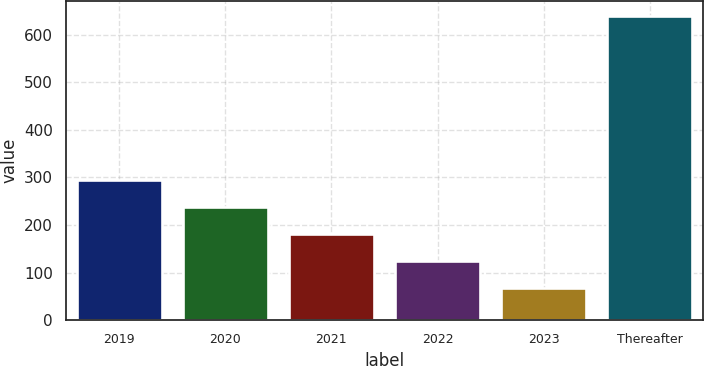<chart> <loc_0><loc_0><loc_500><loc_500><bar_chart><fcel>2019<fcel>2020<fcel>2021<fcel>2022<fcel>2023<fcel>Thereafter<nl><fcel>295.4<fcel>238.3<fcel>181.2<fcel>124.1<fcel>67<fcel>638<nl></chart> 